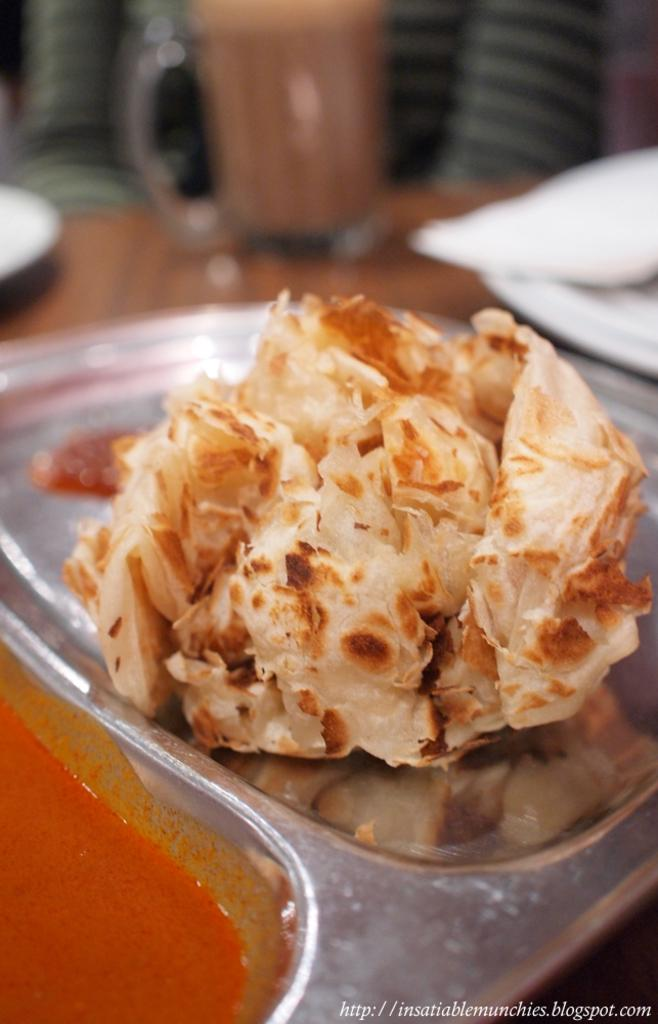What type of food is on the steel plate in the image? There is a chur chur naan on a steel plate in the image. What accompanies the chur chur naan on the plate? There is a curry on the left side of the plate. Can you describe the background of the image? The background of the image is blurred. What type of sheet is covering the chur chur naan in the image? There is no sheet covering the chur chur naan in the image; it is on a steel plate with curry on the left side. 